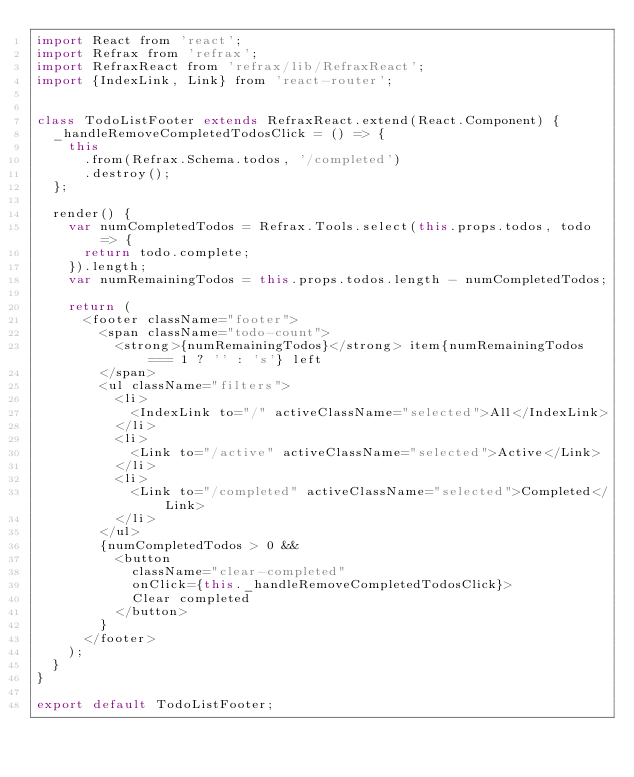Convert code to text. <code><loc_0><loc_0><loc_500><loc_500><_JavaScript_>import React from 'react';
import Refrax from 'refrax';
import RefraxReact from 'refrax/lib/RefraxReact';
import {IndexLink, Link} from 'react-router';


class TodoListFooter extends RefraxReact.extend(React.Component) {
  _handleRemoveCompletedTodosClick = () => {
    this
      .from(Refrax.Schema.todos, '/completed')
      .destroy();
  };

  render() {
    var numCompletedTodos = Refrax.Tools.select(this.props.todos, todo => {
      return todo.complete;
    }).length;
    var numRemainingTodos = this.props.todos.length - numCompletedTodos;

    return (
      <footer className="footer">
        <span className="todo-count">
          <strong>{numRemainingTodos}</strong> item{numRemainingTodos === 1 ? '' : 's'} left
        </span>
        <ul className="filters">
          <li>
            <IndexLink to="/" activeClassName="selected">All</IndexLink>
          </li>
          <li>
            <Link to="/active" activeClassName="selected">Active</Link>
          </li>
          <li>
            <Link to="/completed" activeClassName="selected">Completed</Link>
          </li>
        </ul>
        {numCompletedTodos > 0 &&
          <button
            className="clear-completed"
            onClick={this._handleRemoveCompletedTodosClick}>
            Clear completed
          </button>
        }
      </footer>
    );
  }
}

export default TodoListFooter;
</code> 